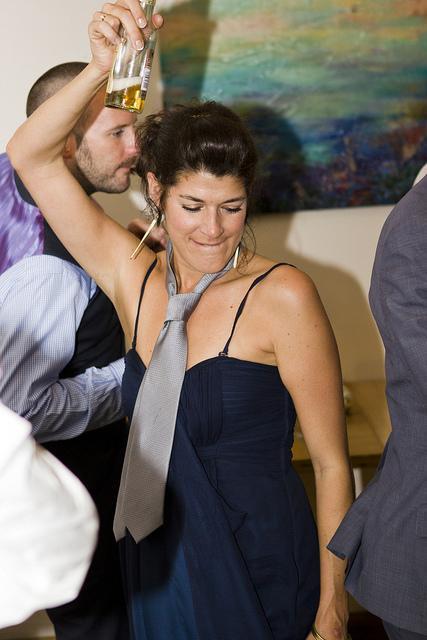How many people are there?
Give a very brief answer. 5. How many bus passengers are visible?
Give a very brief answer. 0. 